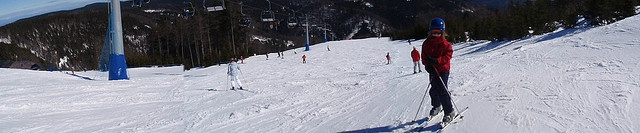Describe the objects in this image and their specific colors. I can see people in gray, black, maroon, and lightgray tones, people in gray, lavender, and darkgray tones, people in gray, maroon, darkgray, and lightgray tones, skis in gray, navy, darkgray, and lightgray tones, and people in gray, darkgray, maroon, lavender, and black tones in this image. 